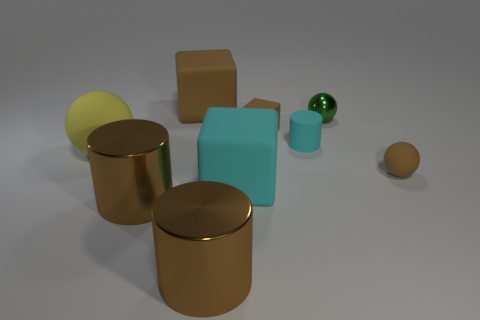What is the shape of the small cyan object that is the same material as the tiny cube?
Provide a short and direct response. Cylinder. Do the cyan matte cylinder and the brown ball have the same size?
Your answer should be compact. Yes. What size is the brown cylinder that is on the left side of the big thing behind the small green ball?
Give a very brief answer. Large. What is the shape of the small object that is the same color as the tiny matte cube?
Keep it short and to the point. Sphere. What number of blocks are gray things or big yellow things?
Offer a terse response. 0. Does the yellow rubber sphere have the same size as the rubber block on the left side of the big cyan rubber thing?
Give a very brief answer. Yes. Is the number of matte objects behind the metallic ball greater than the number of large gray metal things?
Offer a terse response. Yes. The brown ball that is made of the same material as the cyan cube is what size?
Keep it short and to the point. Small. Is there a large metallic cylinder of the same color as the small cube?
Provide a succinct answer. Yes. How many objects are either large yellow matte cylinders or large objects to the right of the yellow thing?
Provide a succinct answer. 4. 